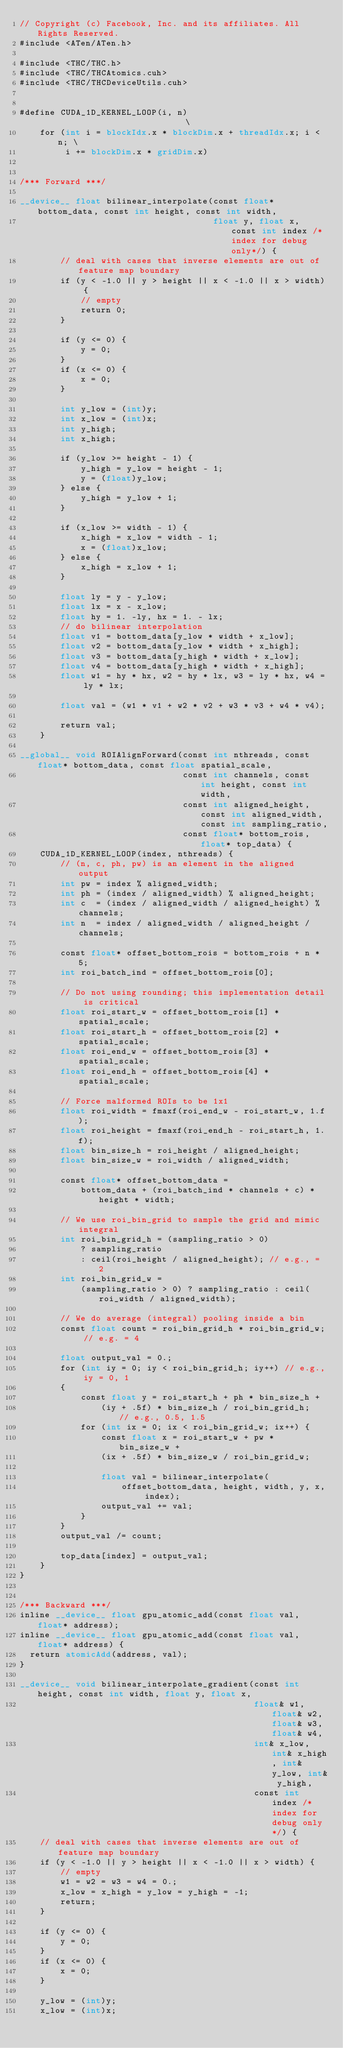Convert code to text. <code><loc_0><loc_0><loc_500><loc_500><_Cuda_>// Copyright (c) Facebook, Inc. and its affiliates. All Rights Reserved.
#include <ATen/ATen.h>

#include <THC/THC.h>
#include <THC/THCAtomics.cuh>
#include <THC/THCDeviceUtils.cuh>


#define CUDA_1D_KERNEL_LOOP(i, n)                              \
    for (int i = blockIdx.x * blockDim.x + threadIdx.x; i < n; \
         i += blockDim.x * gridDim.x)


/*** Forward ***/

__device__ float bilinear_interpolate(const float* bottom_data, const int height, const int width,
                                      float y, float x, const int index /* index for debug only*/) {
        // deal with cases that inverse elements are out of feature map boundary
        if (y < -1.0 || y > height || x < -1.0 || x > width) {
            // empty
            return 0;
        }

        if (y <= 0) {
            y = 0;
        }
        if (x <= 0) {
            x = 0;
        }

        int y_low = (int)y;
        int x_low = (int)x;
        int y_high;
        int x_high;

        if (y_low >= height - 1) {
            y_high = y_low = height - 1;
            y = (float)y_low;
        } else {
            y_high = y_low + 1;
        }

        if (x_low >= width - 1) {
            x_high = x_low = width - 1;
            x = (float)x_low;
        } else {
            x_high = x_low + 1;
        }

        float ly = y - y_low;
        float lx = x - x_low;
        float hy = 1. -ly, hx = 1. - lx;
        // do bilinear interpolation
        float v1 = bottom_data[y_low * width + x_low];
        float v2 = bottom_data[y_low * width + x_high];
        float v3 = bottom_data[y_high * width + x_low];
        float v4 = bottom_data[y_high * width + x_high];
        float w1 = hy * hx, w2 = hy * lx, w3 = ly * hx, w4 = ly * lx;

        float val = (w1 * v1 + w2 * v2 + w3 * v3 + w4 * v4);

        return val;
    }

__global__ void ROIAlignForward(const int nthreads, const float* bottom_data, const float spatial_scale,
                                const int channels, const int height, const int width,
                                const int aligned_height, const int aligned_width, const int sampling_ratio,
                                const float* bottom_rois, float* top_data) {
    CUDA_1D_KERNEL_LOOP(index, nthreads) {
        // (n, c, ph, pw) is an element in the aligned output
        int pw = index % aligned_width;
        int ph = (index / aligned_width) % aligned_height;
        int c  = (index / aligned_width / aligned_height) % channels;
        int n  = index / aligned_width / aligned_height / channels;

        const float* offset_bottom_rois = bottom_rois + n * 5;
        int roi_batch_ind = offset_bottom_rois[0];

        // Do not using rounding; this implementation detail is critical
        float roi_start_w = offset_bottom_rois[1] * spatial_scale;
        float roi_start_h = offset_bottom_rois[2] * spatial_scale;
        float roi_end_w = offset_bottom_rois[3] * spatial_scale;
        float roi_end_h = offset_bottom_rois[4] * spatial_scale;

        // Force malformed ROIs to be 1x1
        float roi_width = fmaxf(roi_end_w - roi_start_w, 1.f);
        float roi_height = fmaxf(roi_end_h - roi_start_h, 1.f);
        float bin_size_h = roi_height / aligned_height;
        float bin_size_w = roi_width / aligned_width;

        const float* offset_bottom_data =
            bottom_data + (roi_batch_ind * channels + c) * height * width;

        // We use roi_bin_grid to sample the grid and mimic integral
        int roi_bin_grid_h = (sampling_ratio > 0)
            ? sampling_ratio
            : ceil(roi_height / aligned_height); // e.g., = 2
        int roi_bin_grid_w =
            (sampling_ratio > 0) ? sampling_ratio : ceil(roi_width / aligned_width);

        // We do average (integral) pooling inside a bin
        const float count = roi_bin_grid_h * roi_bin_grid_w; // e.g. = 4

        float output_val = 0.;
        for (int iy = 0; iy < roi_bin_grid_h; iy++) // e.g., iy = 0, 1
        {
            const float y = roi_start_h + ph * bin_size_h +
                (iy + .5f) * bin_size_h / roi_bin_grid_h;  // e.g., 0.5, 1.5
            for (int ix = 0; ix < roi_bin_grid_w; ix++) {
                const float x = roi_start_w + pw * bin_size_w +
                (ix + .5f) * bin_size_w / roi_bin_grid_w;

                float val = bilinear_interpolate(
                    offset_bottom_data, height, width, y, x, index);
                output_val += val;
            }
        }
        output_val /= count;

        top_data[index] = output_val;
    }
}


/*** Backward ***/
inline __device__ float gpu_atomic_add(const float val, float* address);
inline __device__ float gpu_atomic_add(const float val, float* address) {
  return atomicAdd(address, val);
}

__device__ void bilinear_interpolate_gradient(const int height, const int width, float y, float x,
                                              float& w1, float& w2, float& w3, float& w4,
                                              int& x_low, int& x_high, int& y_low, int& y_high,
                                              const int index /* index for debug only*/) {
    // deal with cases that inverse elements are out of feature map boundary
    if (y < -1.0 || y > height || x < -1.0 || x > width) {
        // empty
        w1 = w2 = w3 = w4 = 0.;
        x_low = x_high = y_low = y_high = -1;
        return;
    }

    if (y <= 0) {
        y = 0;
    }
    if (x <= 0) {
        x = 0;
    }

    y_low = (int)y;
    x_low = (int)x;
</code> 